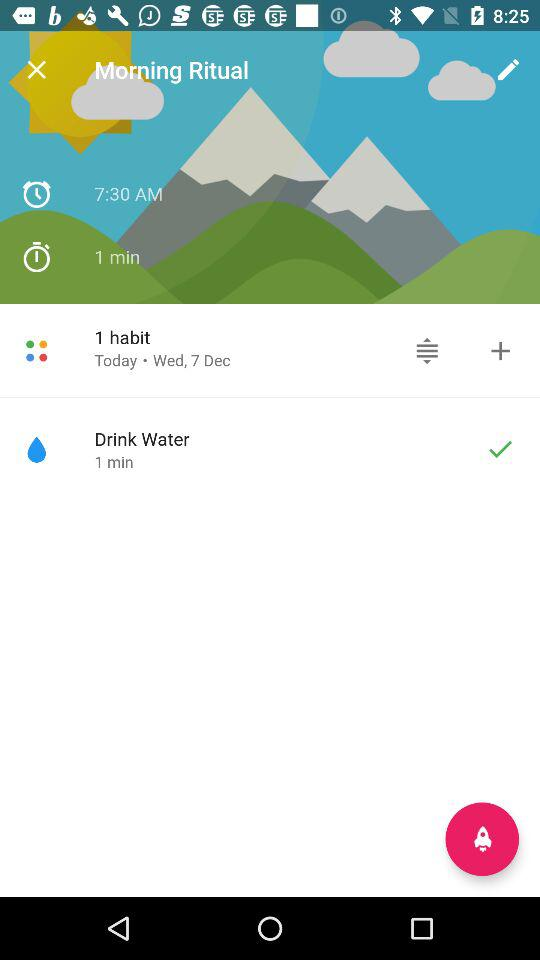What is the time? The time is 7:30 AM. 